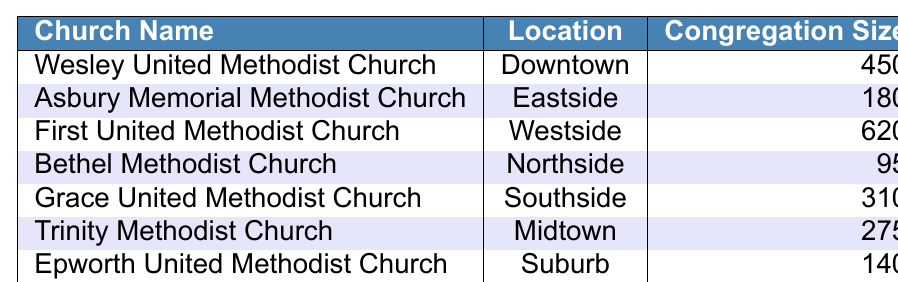What is the congregation size of the First United Methodist Church? The table shows that the congregation size for the First United Methodist Church is listed as 620.
Answer: 620 Which church has the smallest congregation size? The smallest congregation size in the table is for New Hope Methodist Church, which has a size of 75.
Answer: New Hope Methodist Church What is the total congregation size of all the churches combined? To find the total, we sum all congregation sizes: 450 + 180 + 620 + 95 + 310 + 275 + 140 + 75 = 2105.
Answer: 2105 Is there a church located in the Eastside? Yes, the Asbury Memorial Methodist Church is located in the Eastside according to the table.
Answer: Yes How many churches have a congregation size of over 300? From the table, the churches with congregation sizes over 300 are: First United Methodist Church (620), Wesley United Methodist Church (450), and Grace United Methodist Church (310). That makes it a total of 3 churches.
Answer: 3 What is the average congregation size of the listed churches? To find the average, we take the total congregation size (2105) and divide it by the number of churches (8): 2105 / 8 = 263.125.
Answer: 263.125 Which church is located in the Rural area? The New Hope Methodist Church is indicated as being located in the Rural area in the table.
Answer: New Hope Methodist Church What is the difference in congregation size between the largest and smallest church? The largest congregation is from the First United Methodist Church with 620, and the smallest is New Hope Methodist Church with 75. The difference is 620 - 75 = 545.
Answer: 545 Are there any churches with a congregation size less than 100? Yes, the Bethel Methodist Church (95) and New Hope Methodist Church (75) have congregation sizes less than 100.
Answer: Yes Which church is located in Midtown and what is its congregation size? Trinity Methodist Church is located in Midtown and has a congregation size of 275, as shown in the table.
Answer: Trinity Methodist Church, 275 